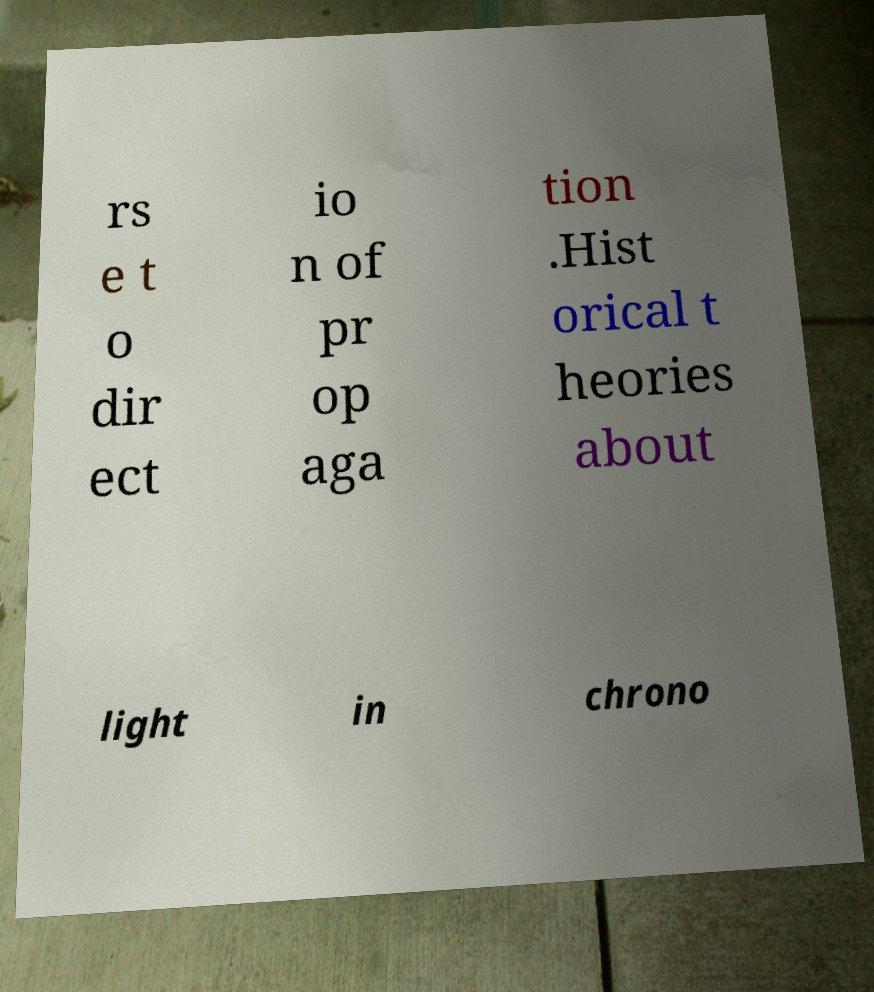Please read and relay the text visible in this image. What does it say? rs e t o dir ect io n of pr op aga tion .Hist orical t heories about light in chrono 